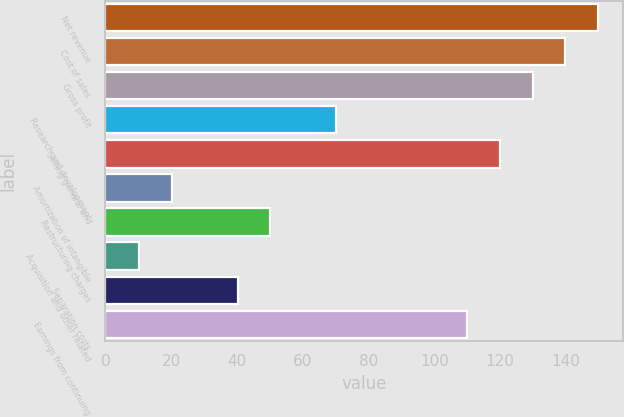Convert chart to OTSL. <chart><loc_0><loc_0><loc_500><loc_500><bar_chart><fcel>Net revenue<fcel>Cost of sales<fcel>Gross profit<fcel>Research and development<fcel>Selling general and<fcel>Amortization of intangible<fcel>Restructuring charges<fcel>Acquisition and other related<fcel>Separation costs<fcel>Earnings from continuing<nl><fcel>149.85<fcel>139.88<fcel>129.91<fcel>70.09<fcel>119.94<fcel>20.24<fcel>50.15<fcel>10.27<fcel>40.18<fcel>109.97<nl></chart> 